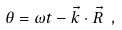Convert formula to latex. <formula><loc_0><loc_0><loc_500><loc_500>\theta = \omega t - \vec { k } \cdot \vec { R } \ ,</formula> 